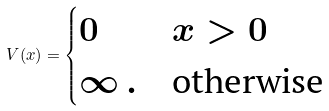Convert formula to latex. <formula><loc_0><loc_0><loc_500><loc_500>V ( x ) = \begin{cases} 0 & \text {$x>0$} \\ \infty \, . & \text {otherwise} \end{cases}</formula> 